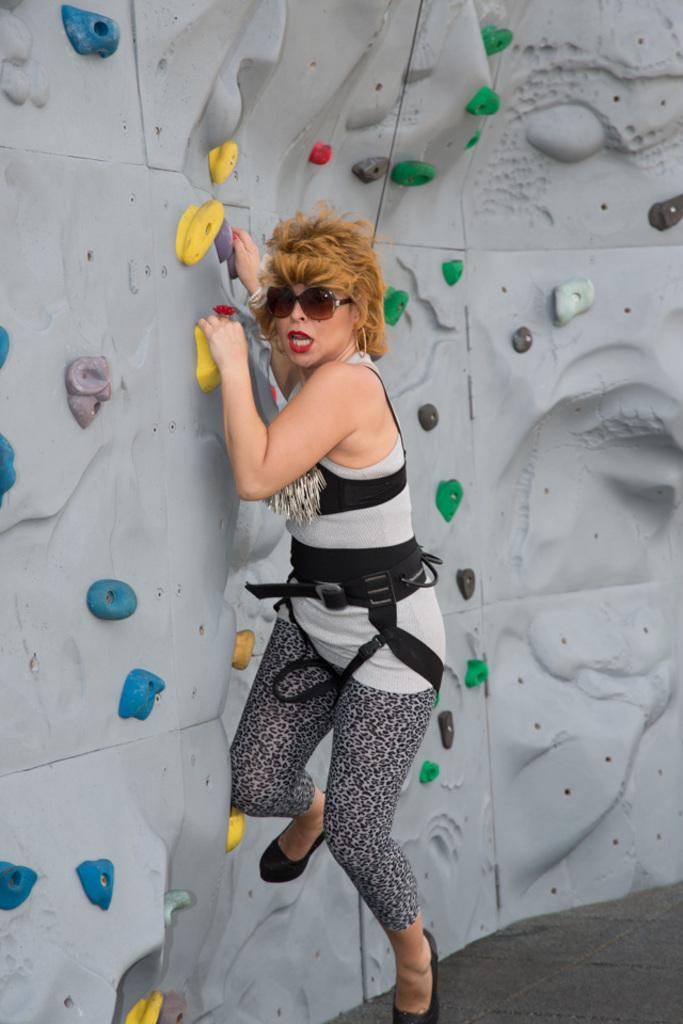Who is present in the image? There is a woman in the image. What can be seen towards the top of the image? There is a rope towards the top of the image. What is visible in the background of the image? There is a wall in the background of the image. What is on the wall? There are objects on the wall. How does the woman maintain a quiet environment in the image? The image does not provide information about the woman's actions or the environment's noise level, so it cannot be determined if she is maintaining a quiet environment. 